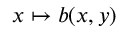<formula> <loc_0><loc_0><loc_500><loc_500>x \mapsto b ( x , y )</formula> 